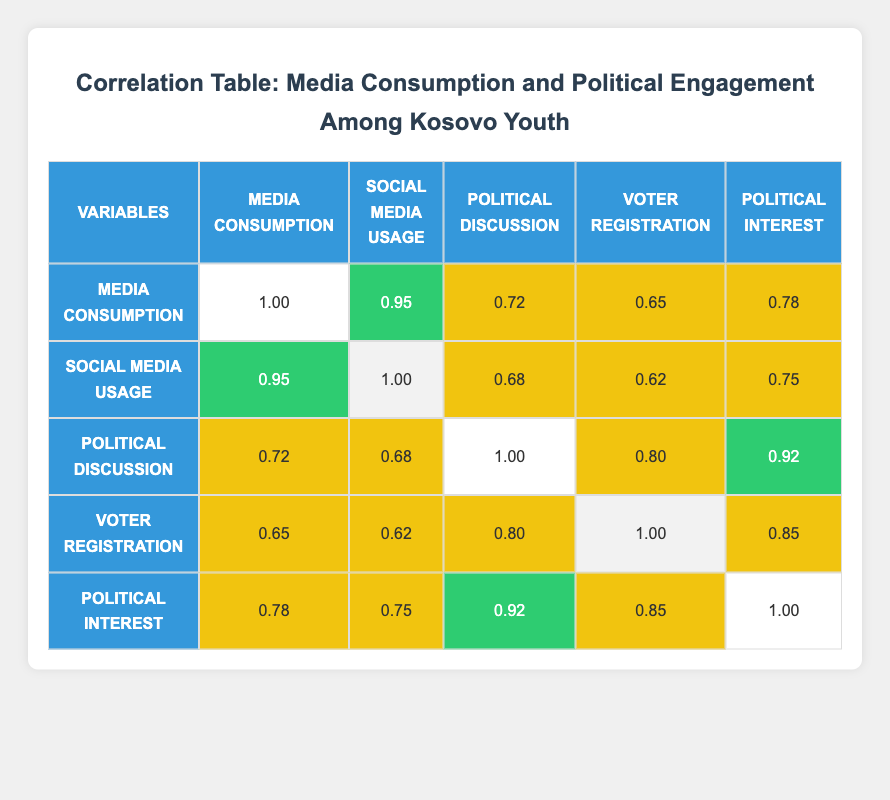What is the correlation coefficient between media consumption and political discussions? The table shows that the correlation coefficient between media consumption and political discussions is 0.72. This value can be found in the intersection of the "Media Consumption" row and the "Political Discussion" column.
Answer: 0.72 Is there a high correlation between social media usage and voter registration? The correlation coefficient between social media usage and voter registration is 0.62, which indicates a medium correlation rather than a high one. This value is located in the "Social Media Usage" row and the "Voter Registration" column.
Answer: No What is the highest correlation value in the table? The highest correlation value is 0.95, which is the correlation between media consumption and social media usage. This can be read directly from the table in the corresponding intersection.
Answer: 0.95 What is the average correlation between political interest and the other variables? To find the average, we sum the correlation values with political interest (0.78, 0.75, 0.92, 0.85) and divide by the number of values (4). The total is 0.78 + 0.75 + 0.92 + 0.85 = 3.30, and when divided by 4, the average is 3.30 / 4 = 0.825.
Answer: 0.825 Is there a correlation between media consumption and voter registration that is considered medium or higher? Yes, the correlation between media consumption and voter registration is 0.65, which is classified as medium. This information can be found at the intersection of the "Media Consumption" row and "Voter Registration" column.
Answer: Yes How does the correlation between political discussions and political interest compare to that of media consumption and political interest? The correlation between political discussions and political interest is 0.92, while the correlation between media consumption and political interest is 0.78. Since 0.92 is greater than 0.78, political discussions have a higher correlation with political interest. These values can be compared directly from the respective rows and columns of the table.
Answer: Political discussions have a higher correlation with political interest 